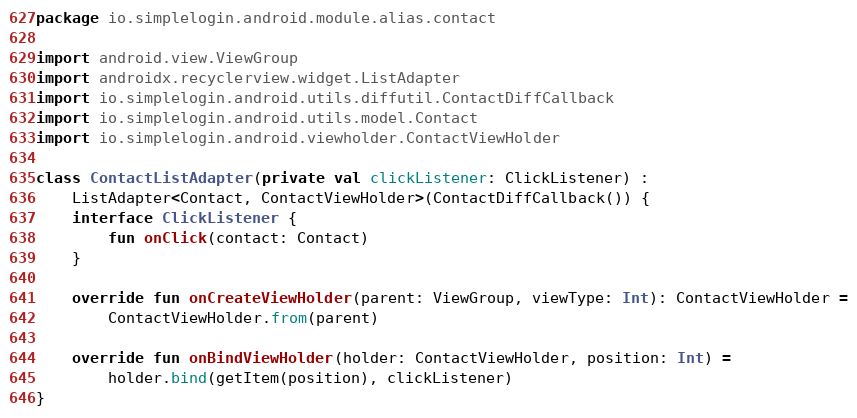<code> <loc_0><loc_0><loc_500><loc_500><_Kotlin_>package io.simplelogin.android.module.alias.contact

import android.view.ViewGroup
import androidx.recyclerview.widget.ListAdapter
import io.simplelogin.android.utils.diffutil.ContactDiffCallback
import io.simplelogin.android.utils.model.Contact
import io.simplelogin.android.viewholder.ContactViewHolder

class ContactListAdapter(private val clickListener: ClickListener) :
    ListAdapter<Contact, ContactViewHolder>(ContactDiffCallback()) {
    interface ClickListener {
        fun onClick(contact: Contact)
    }

    override fun onCreateViewHolder(parent: ViewGroup, viewType: Int): ContactViewHolder =
        ContactViewHolder.from(parent)

    override fun onBindViewHolder(holder: ContactViewHolder, position: Int) =
        holder.bind(getItem(position), clickListener)
}
</code> 